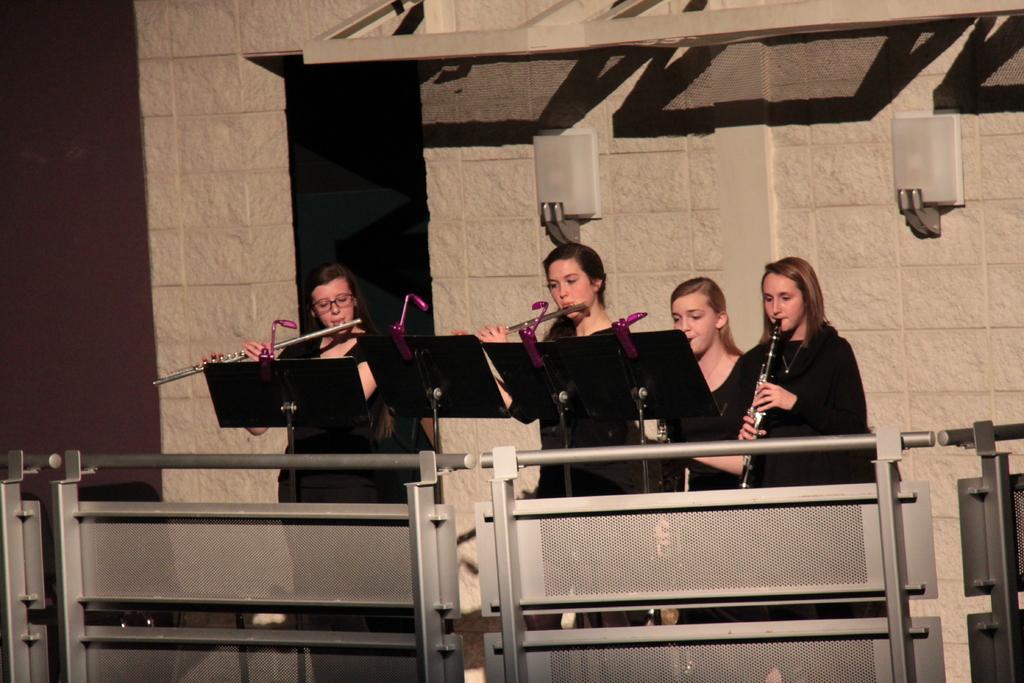Could you give a brief overview of what you see in this image? In the center of the image there are women playing musical instruments. In the background of the image there is wall. At the front of the image there is a fencing. 